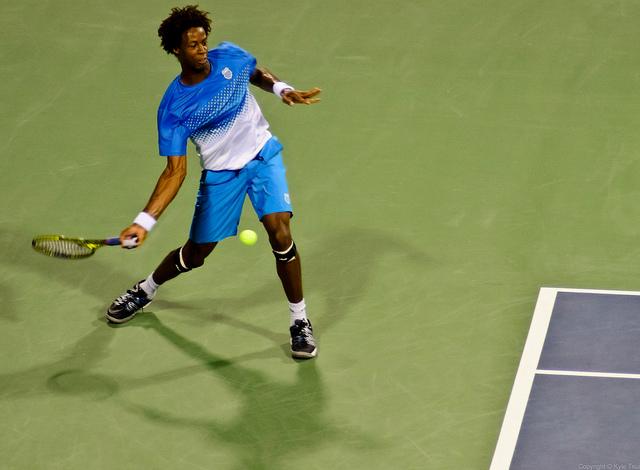Is the person holding the ball?
Quick response, please. No. What kind of surface are they playing on?
Quick response, please. Clay. What color is the man's shorts?
Short answer required. Blue. Is his shirt tucked in?
Quick response, please. No. What sport is the person playing?
Short answer required. Tennis. What color is the court?
Short answer required. Green. How long has this man been a tennis player?
Be succinct. 10 years. What gender is the closest person?
Short answer required. Male. What color is the man wearing?
Answer briefly. Blue. Is the man in a gym?
Concise answer only. No. How many feet are on the ground?
Answer briefly. 2. 